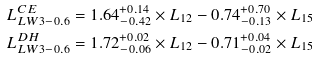Convert formula to latex. <formula><loc_0><loc_0><loc_500><loc_500>& L _ { L W 3 - 0 . 6 } ^ { C E } = 1 . 6 4 _ { - 0 . 4 2 } ^ { + 0 . 1 4 } \times L _ { 1 2 } - 0 . 7 4 _ { - 0 . 1 3 } ^ { + 0 . 7 0 } \times L _ { 1 5 } \\ & L _ { L W 3 - 0 . 6 } ^ { D H } = 1 . 7 2 _ { - 0 . 0 6 } ^ { + 0 . 0 2 } \times L _ { 1 2 } - 0 . 7 1 _ { - 0 . 0 2 } ^ { + 0 . 0 4 } \times L _ { 1 5 }</formula> 